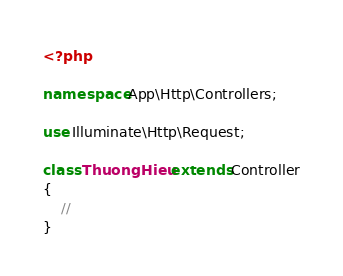Convert code to text. <code><loc_0><loc_0><loc_500><loc_500><_PHP_><?php

namespace App\Http\Controllers;

use Illuminate\Http\Request;

class ThuongHieu extends Controller
{
    //
}
</code> 